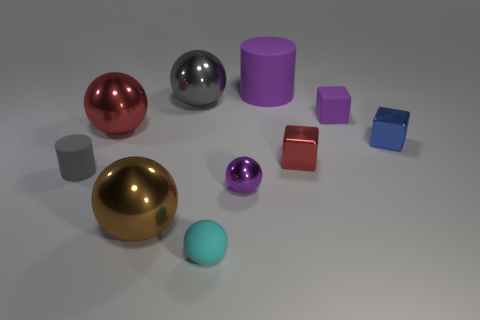Subtract all cyan balls. How many balls are left? 4 Subtract all small matte balls. How many balls are left? 4 Subtract all blue balls. Subtract all green cylinders. How many balls are left? 5 Subtract all blocks. How many objects are left? 7 Add 6 purple balls. How many purple balls are left? 7 Add 3 purple spheres. How many purple spheres exist? 4 Subtract 0 green balls. How many objects are left? 10 Subtract all small purple matte blocks. Subtract all large red spheres. How many objects are left? 8 